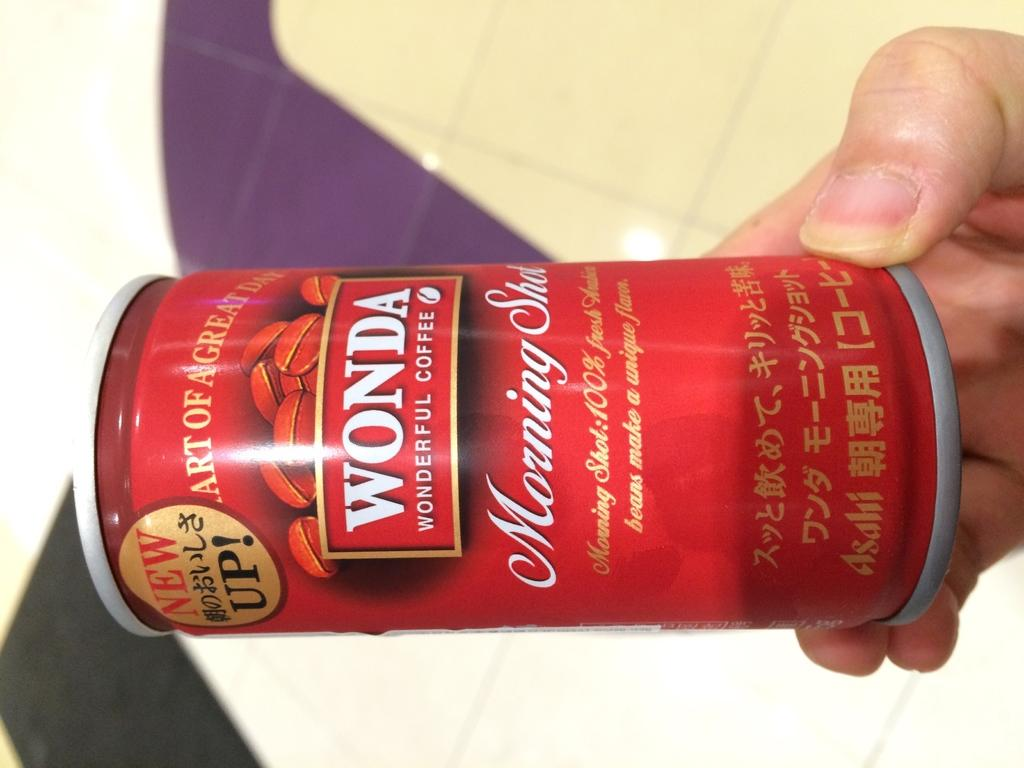<image>
Offer a succinct explanation of the picture presented. A red can of Wonda wonderful coffee is being held up by a hand. 